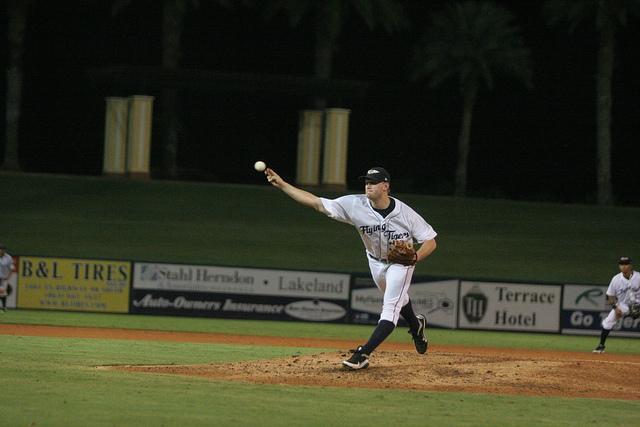Who sponsors this baseball team?
Be succinct. Terrace hotel. What is the pitcher's throwing handedness?
Answer briefly. Right. How many different advertisements can you spot?
Short answer required. 5. What color are the numbers on the fence?
Write a very short answer. White. Is the pitcher wearing a standard baseball uniform?
Keep it brief. Yes. Is there someone holding a bat?
Write a very short answer. No. What does the man have in his hand?
Keep it brief. Baseball. What team is he on?
Concise answer only. Flying tigers. What team does the pitcher play for?
Be succinct. Flying tigers. Could this be a left-handed pitcher?
Be succinct. No. What is written on the white shirt?
Keep it brief. Flying tigers. What color is the ball?
Concise answer only. White. Does this game take place during the day?
Write a very short answer. No. What is the pitcher looking at?
Keep it brief. Batter. What motel is on the add?
Answer briefly. Terrace hotel. What sport is being played?
Answer briefly. Baseball. Which of the pitchers hands has the glove?
Concise answer only. Left. Is there an audience?
Quick response, please. No. What color is the pitcher wearing?
Write a very short answer. White. 